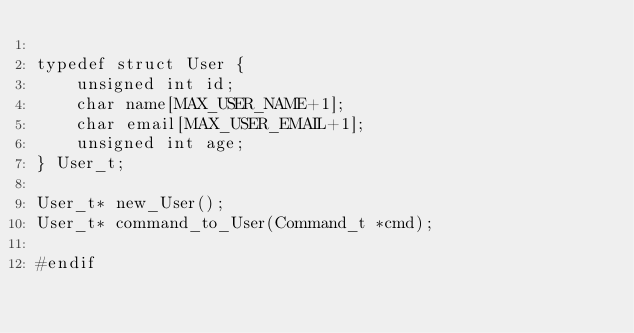<code> <loc_0><loc_0><loc_500><loc_500><_C_>
typedef struct User {
    unsigned int id;
    char name[MAX_USER_NAME+1];
    char email[MAX_USER_EMAIL+1];
    unsigned int age;
} User_t;

User_t* new_User();
User_t* command_to_User(Command_t *cmd);

#endif
</code> 